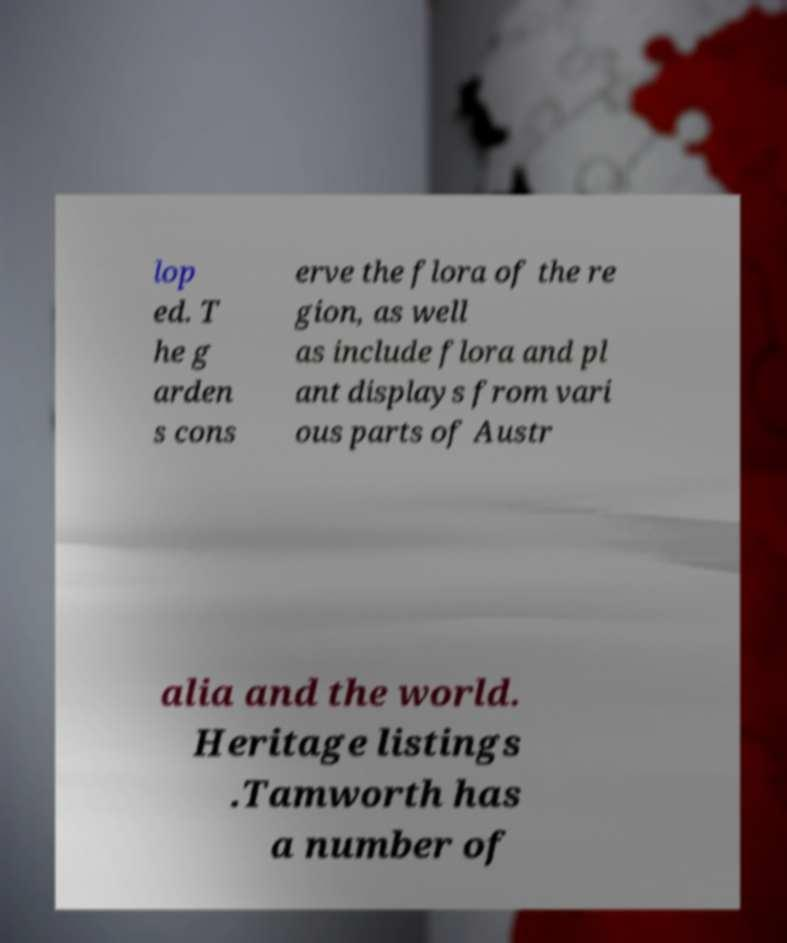Can you accurately transcribe the text from the provided image for me? lop ed. T he g arden s cons erve the flora of the re gion, as well as include flora and pl ant displays from vari ous parts of Austr alia and the world. Heritage listings .Tamworth has a number of 